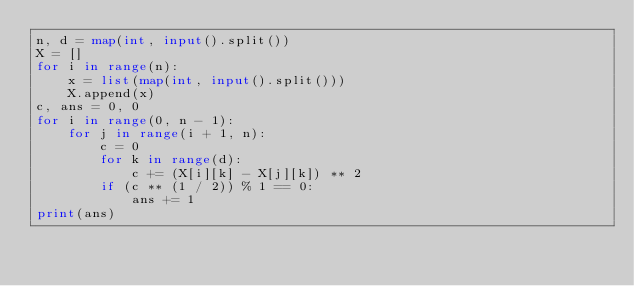<code> <loc_0><loc_0><loc_500><loc_500><_Python_>n, d = map(int, input().split())
X = []
for i in range(n):
    x = list(map(int, input().split()))
    X.append(x)
c, ans = 0, 0
for i in range(0, n - 1):
    for j in range(i + 1, n):
        c = 0
        for k in range(d):
            c += (X[i][k] - X[j][k]) ** 2
        if (c ** (1 / 2)) % 1 == 0:
            ans += 1
print(ans)</code> 